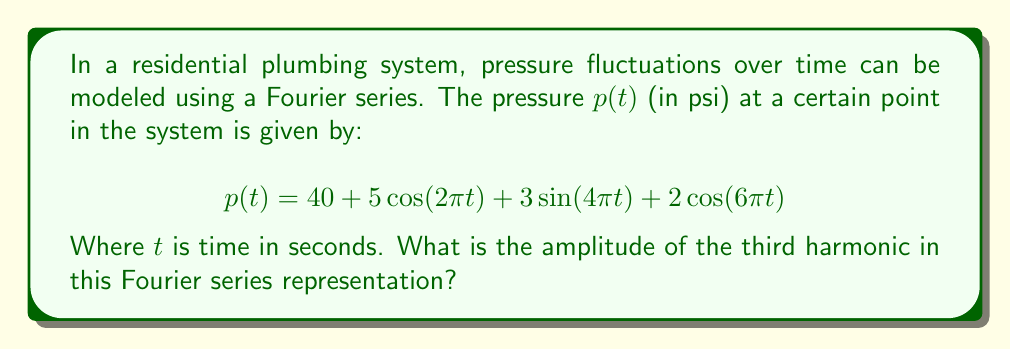Solve this math problem. Let's break this down step-by-step:

1) First, recall that a general Fourier series has the form:

   $$f(t) = a_0 + \sum_{n=1}^{\infty} [a_n \cos(n\omega t) + b_n \sin(n\omega t)]$$

   Where $a_0$ is the constant term, and $a_n$ and $b_n$ are the coefficients of the cosine and sine terms respectively.

2) In our pressure function:
   
   $$p(t) = 40 + 5\cos(2\pi t) + 3\sin(4\pi t) + 2\cos(6\pi t)$$

   We can identify:
   - $a_0 = 40$ (constant term)
   - First harmonic: $5\cos(2\pi t)$
   - Second harmonic: $3\sin(4\pi t)$
   - Third harmonic: $2\cos(6\pi t)$

3) The amplitude of a harmonic in a Fourier series is given by $\sqrt{a_n^2 + b_n^2}$, where $a_n$ is the coefficient of the cosine term and $b_n$ is the coefficient of the sine term for that harmonic.

4) For the third harmonic:
   - $a_3 = 2$ (coefficient of $\cos(6\pi t)$)
   - $b_3 = 0$ (there is no $\sin(6\pi t)$ term)

5) Therefore, the amplitude of the third harmonic is:

   $$\sqrt{a_3^2 + b_3^2} = \sqrt{2^2 + 0^2} = \sqrt{4} = 2$$

Thus, the amplitude of the third harmonic is 2 psi.
Answer: 2 psi 